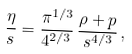Convert formula to latex. <formula><loc_0><loc_0><loc_500><loc_500>\frac { \eta } { s } = \frac { \pi ^ { 1 / 3 } } { 4 ^ { 2 / 3 } } \, \frac { \rho + p } { s ^ { 4 / 3 } } \, ,</formula> 